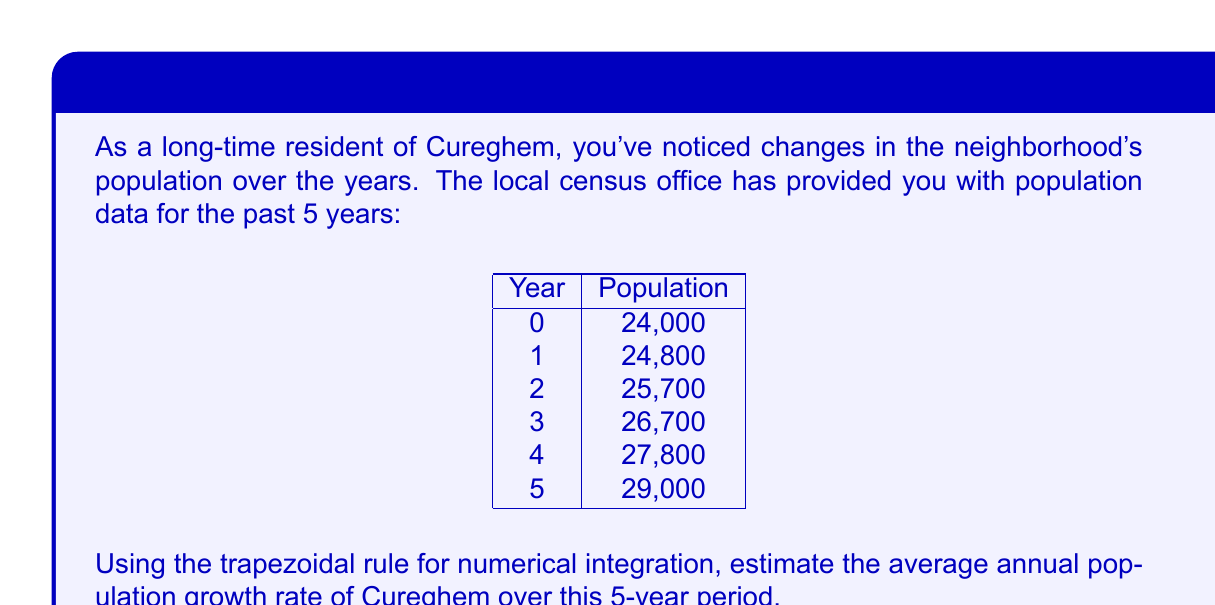What is the answer to this math problem? To estimate the average annual population growth rate using numerical integration, we'll follow these steps:

1) First, we need to calculate the relative population growth for each year:
   $$r_i = \frac{P_{i+1} - P_i}{P_i}$$
   where $P_i$ is the population at year $i$.

   Year 0-1: $r_0 = \frac{24800 - 24000}{24000} = 0.0333$
   Year 1-2: $r_1 = \frac{25700 - 24800}{24800} = 0.0363$
   Year 2-3: $r_2 = \frac{26700 - 25700}{25700} = 0.0389$
   Year 3-4: $r_3 = \frac{27800 - 26700}{26700} = 0.0412$
   Year 4-5: $r_4 = \frac{29000 - 27800}{27800} = 0.0432$

2) Now, we'll use the trapezoidal rule to estimate the integral of the growth rate function:
   $$\int_0^5 r(t) dt \approx \frac{1}{2} \sum_{i=0}^{4} (r_i + r_{i+1})$$

3) Applying the formula:
   $$\frac{1}{2}[(0.0333 + 0.0363) + (0.0363 + 0.0389) + (0.0389 + 0.0412) + (0.0412 + 0.0432)] = 0.1921$$

4) To get the average annual growth rate, we divide by the number of years:
   $$\text{Average annual growth rate} = \frac{0.1921}{5} = 0.03842$$

5) Convert to percentage:
   $$0.03842 \times 100\% = 3.842\%$$

Therefore, the estimated average annual population growth rate of Cureghem over the 5-year period is approximately 3.842%.
Answer: 3.842% 